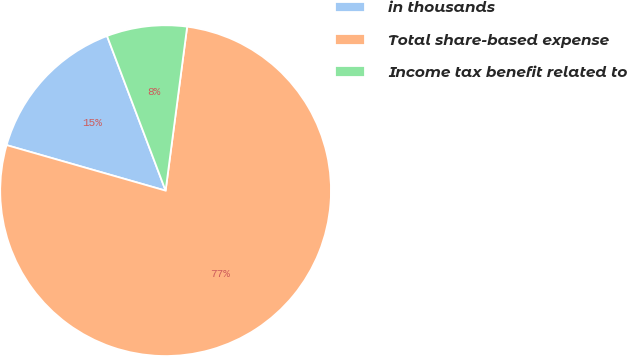Convert chart. <chart><loc_0><loc_0><loc_500><loc_500><pie_chart><fcel>in thousands<fcel>Total share-based expense<fcel>Income tax benefit related to<nl><fcel>14.8%<fcel>77.36%<fcel>7.84%<nl></chart> 